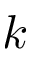Convert formula to latex. <formula><loc_0><loc_0><loc_500><loc_500>k</formula> 